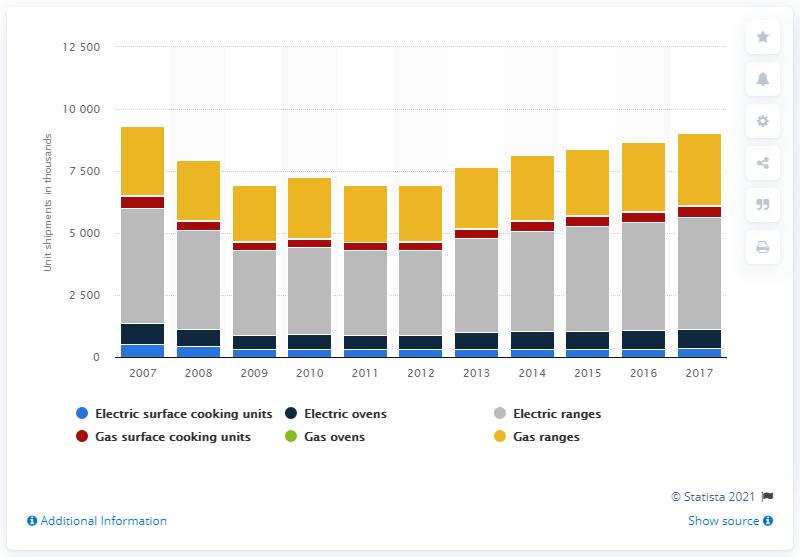Outline some significant characteristics in this image. Appliance Magazine forecasts that unit shipments of electric and gas cooking appliances will occur in 2017. 